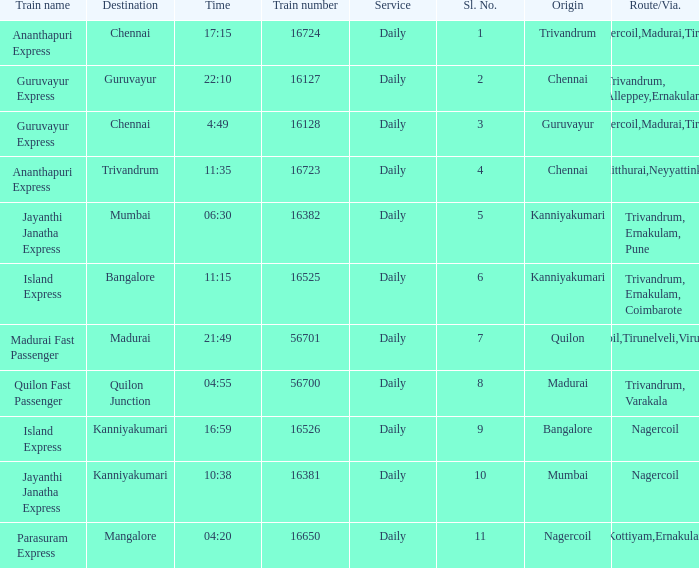What is the origin when the destination is Mumbai? Kanniyakumari. 